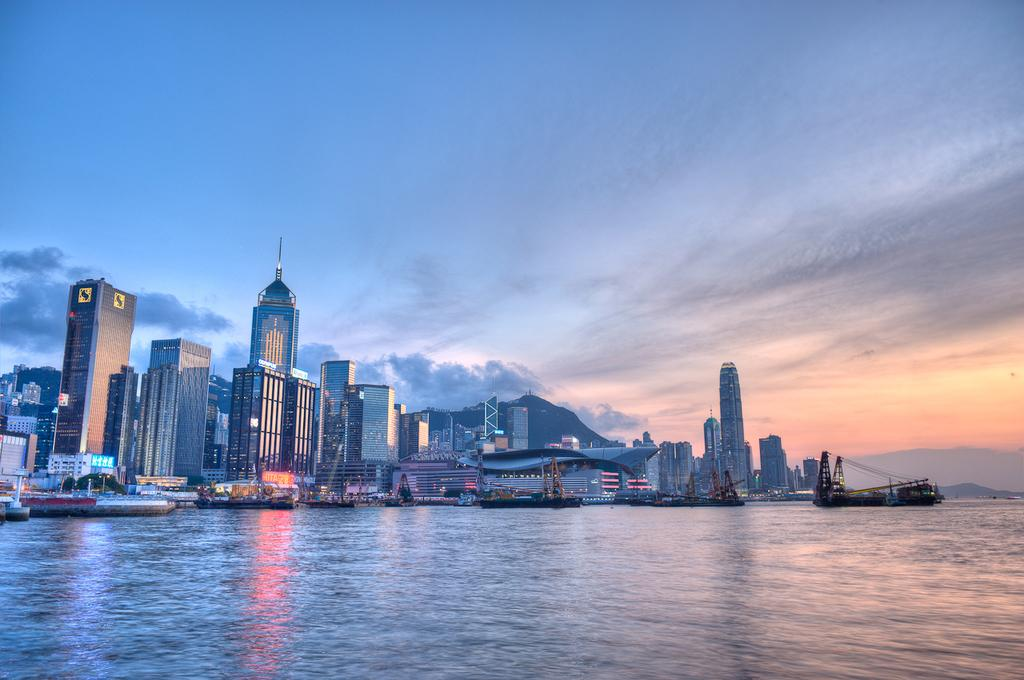What is on the water in the image? There are ships on the water in the image. What can be seen in the distance in the image? There are buildings in the background of the image. What else is visible in the background of the image? There are lights and clouds visible in the background of the image. What type of yarn is being used to create the clouds in the image? There is no yarn present in the image, and the clouds are not created using yarn. 